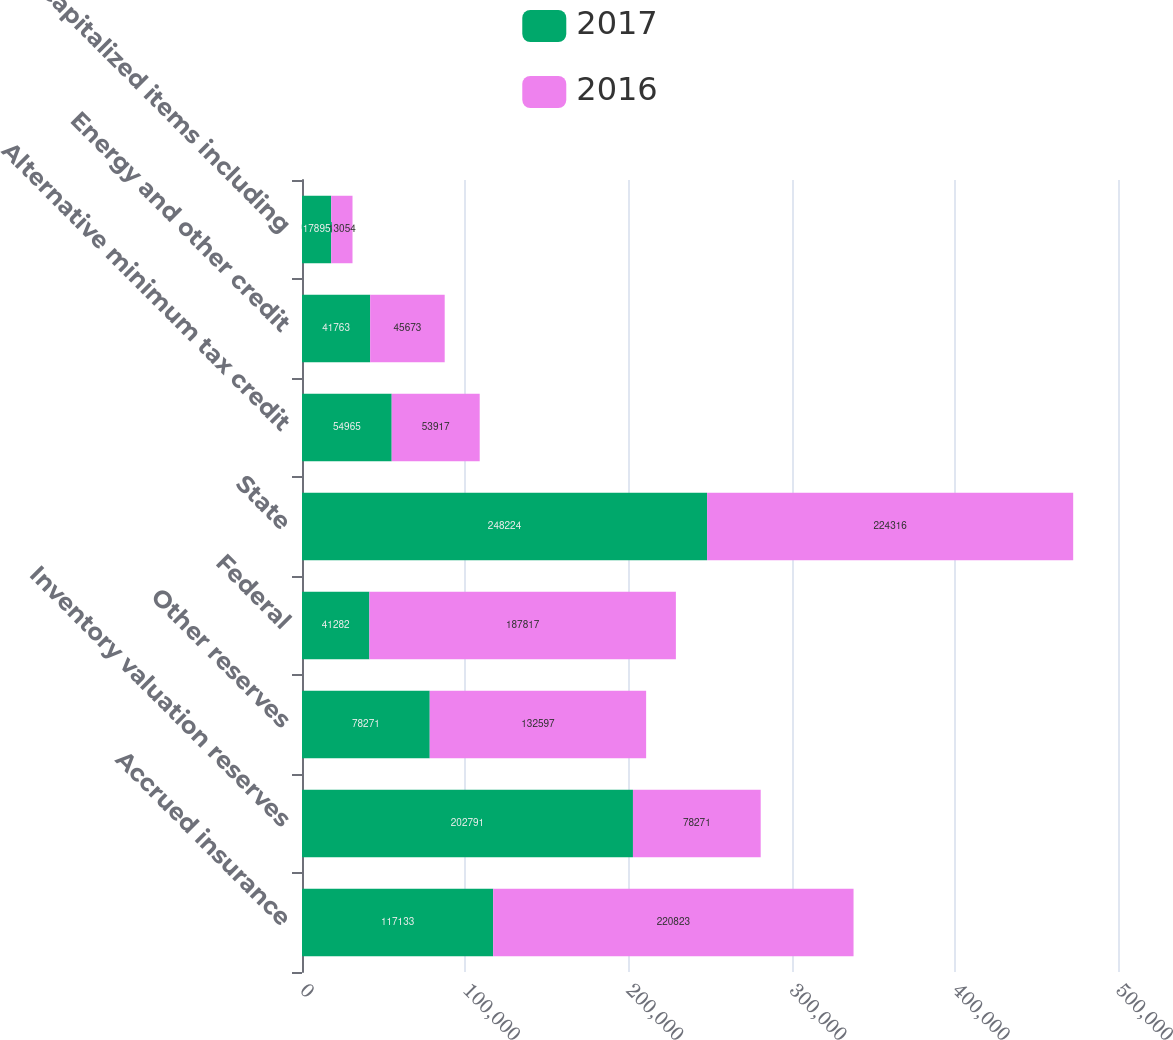Convert chart. <chart><loc_0><loc_0><loc_500><loc_500><stacked_bar_chart><ecel><fcel>Accrued insurance<fcel>Inventory valuation reserves<fcel>Other reserves<fcel>Federal<fcel>State<fcel>Alternative minimum tax credit<fcel>Energy and other credit<fcel>Capitalized items including<nl><fcel>2017<fcel>117133<fcel>202791<fcel>78271<fcel>41282<fcel>248224<fcel>54965<fcel>41763<fcel>17895<nl><fcel>2016<fcel>220823<fcel>78271<fcel>132597<fcel>187817<fcel>224316<fcel>53917<fcel>45673<fcel>13054<nl></chart> 